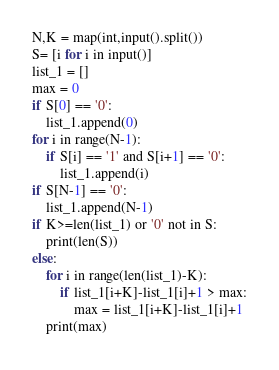<code> <loc_0><loc_0><loc_500><loc_500><_Python_>N,K = map(int,input().split())
S= [i for i in input()]
list_1 = []
max = 0
if S[0] == '0':
	list_1.append(0)
for i in range(N-1):
	if S[i] == '1' and S[i+1] == '0':
		list_1.append(i)
if S[N-1] == '0':
	list_1.append(N-1)
if K>=len(list_1) or '0' not in S:
	print(len(S))
else:
	for i in range(len(list_1)-K):
		if list_1[i+K]-list_1[i]+1 > max:
			max = list_1[i+K]-list_1[i]+1
	print(max)
</code> 